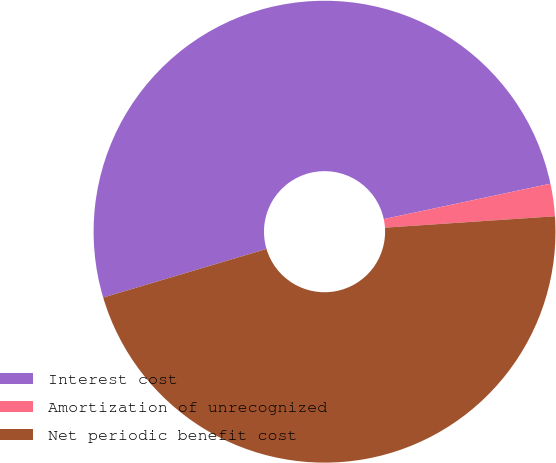Convert chart. <chart><loc_0><loc_0><loc_500><loc_500><pie_chart><fcel>Interest cost<fcel>Amortization of unrecognized<fcel>Net periodic benefit cost<nl><fcel>51.27%<fcel>2.27%<fcel>46.46%<nl></chart> 